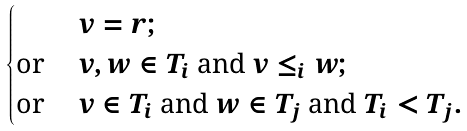Convert formula to latex. <formula><loc_0><loc_0><loc_500><loc_500>\begin{cases} & v = r ; \\ \text {or } & v , w \in T _ { i } \text { and } v \leq _ { i } w ; \\ \text {or } & v \in T _ { i } \text { and } w \in T _ { j } \text { and } T _ { i } < T _ { j } . \end{cases}</formula> 